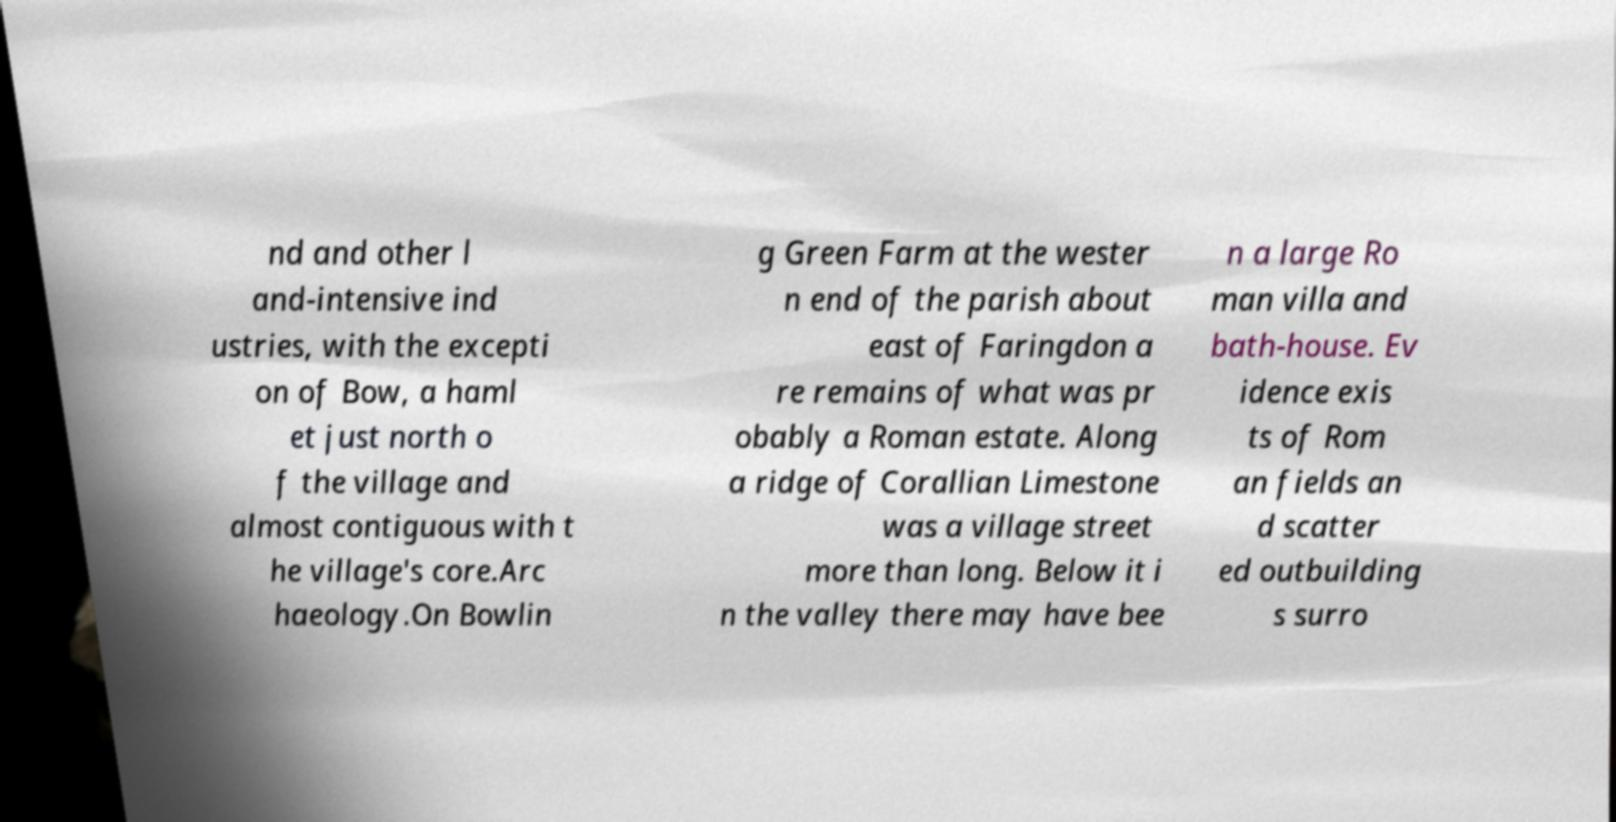What messages or text are displayed in this image? I need them in a readable, typed format. nd and other l and-intensive ind ustries, with the excepti on of Bow, a haml et just north o f the village and almost contiguous with t he village's core.Arc haeology.On Bowlin g Green Farm at the wester n end of the parish about east of Faringdon a re remains of what was pr obably a Roman estate. Along a ridge of Corallian Limestone was a village street more than long. Below it i n the valley there may have bee n a large Ro man villa and bath-house. Ev idence exis ts of Rom an fields an d scatter ed outbuilding s surro 